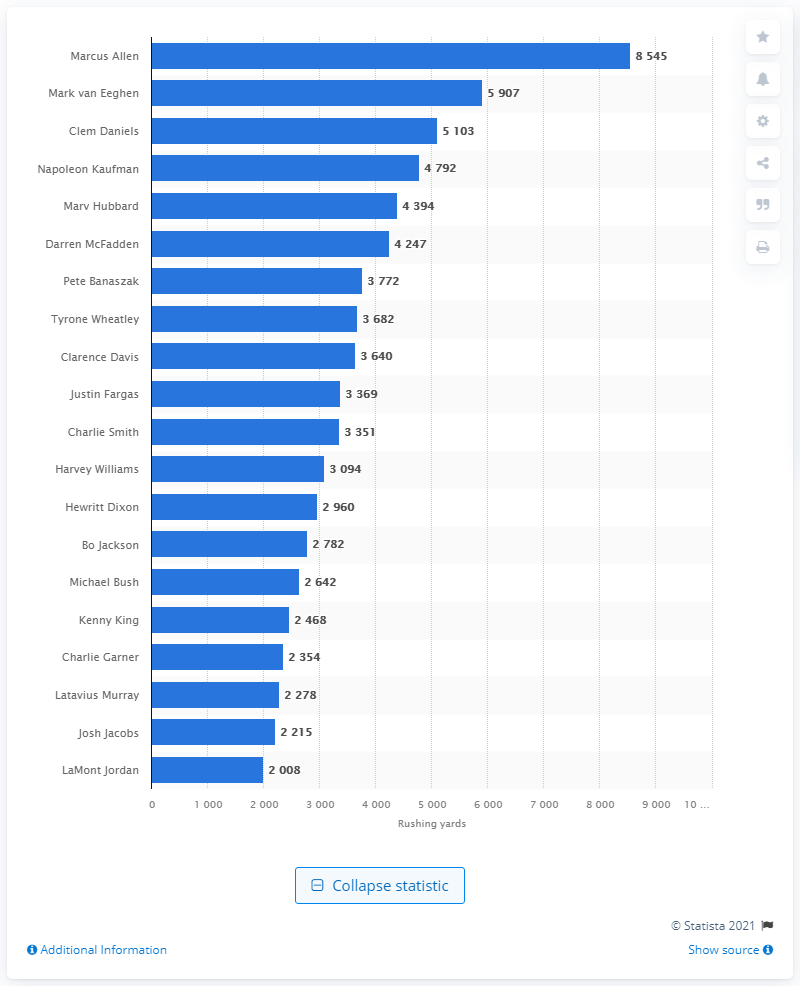Specify some key components in this picture. Marcus Allen is the career rushing leader of the Las Vegas Raiders. 